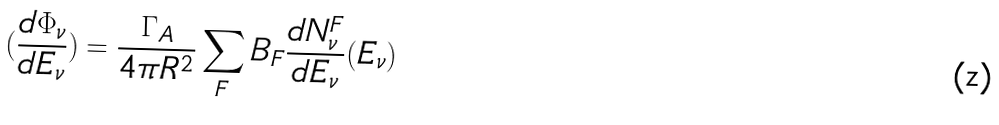<formula> <loc_0><loc_0><loc_500><loc_500>( \frac { d \Phi _ { \nu } } { d E _ { \nu } } ) = \frac { \Gamma _ { A } } { 4 \pi R ^ { 2 } } \sum _ { F } B _ { F } \frac { d N ^ { F } _ { \nu } } { d E _ { \nu } } ( E _ { \nu } )</formula> 